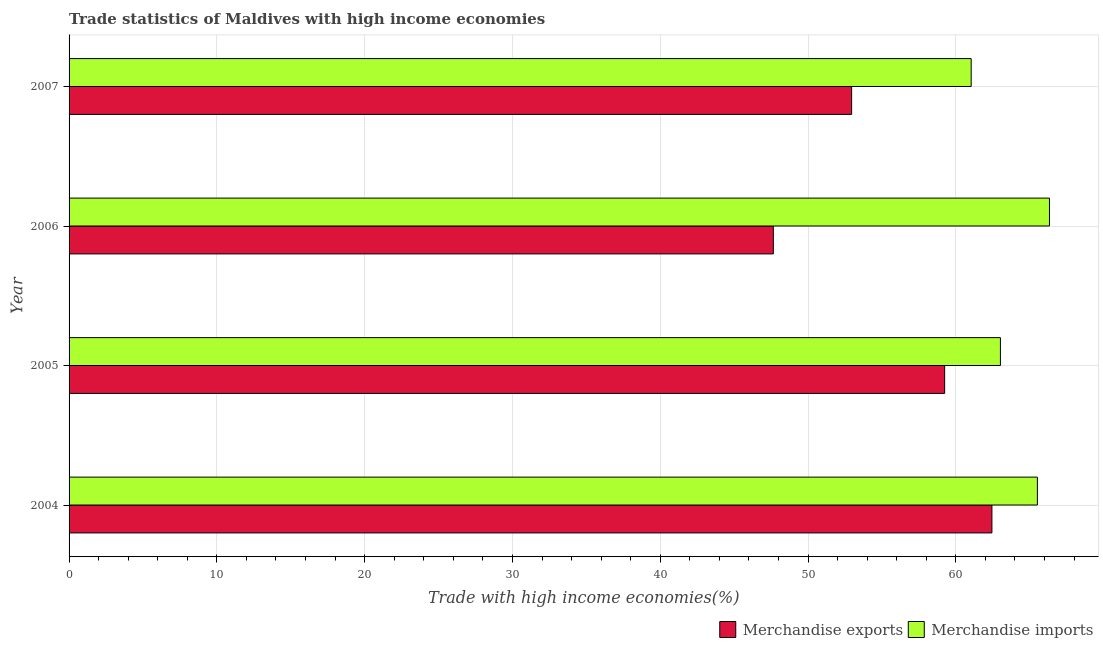How many different coloured bars are there?
Your answer should be compact. 2. How many groups of bars are there?
Keep it short and to the point. 4. Are the number of bars on each tick of the Y-axis equal?
Offer a terse response. Yes. How many bars are there on the 2nd tick from the top?
Your answer should be very brief. 2. How many bars are there on the 4th tick from the bottom?
Keep it short and to the point. 2. In how many cases, is the number of bars for a given year not equal to the number of legend labels?
Your response must be concise. 0. What is the merchandise imports in 2006?
Offer a terse response. 66.34. Across all years, what is the maximum merchandise imports?
Your response must be concise. 66.34. Across all years, what is the minimum merchandise imports?
Provide a short and direct response. 61.04. What is the total merchandise imports in the graph?
Keep it short and to the point. 255.92. What is the difference between the merchandise exports in 2004 and that in 2007?
Offer a very short reply. 9.49. What is the difference between the merchandise imports in 2006 and the merchandise exports in 2005?
Offer a very short reply. 7.09. What is the average merchandise imports per year?
Give a very brief answer. 63.98. In the year 2005, what is the difference between the merchandise exports and merchandise imports?
Your answer should be compact. -3.77. In how many years, is the merchandise exports greater than 42 %?
Offer a very short reply. 4. What is the ratio of the merchandise exports in 2004 to that in 2005?
Offer a very short reply. 1.05. Is the merchandise exports in 2004 less than that in 2005?
Provide a succinct answer. No. What is the difference between the highest and the second highest merchandise imports?
Make the answer very short. 0.82. What is the difference between the highest and the lowest merchandise imports?
Offer a terse response. 5.3. What does the 2nd bar from the top in 2006 represents?
Your answer should be compact. Merchandise exports. What does the 1st bar from the bottom in 2004 represents?
Provide a short and direct response. Merchandise exports. How many bars are there?
Your response must be concise. 8. Are all the bars in the graph horizontal?
Provide a succinct answer. Yes. How many years are there in the graph?
Give a very brief answer. 4. What is the difference between two consecutive major ticks on the X-axis?
Ensure brevity in your answer.  10. Does the graph contain any zero values?
Provide a short and direct response. No. What is the title of the graph?
Keep it short and to the point. Trade statistics of Maldives with high income economies. What is the label or title of the X-axis?
Offer a very short reply. Trade with high income economies(%). What is the Trade with high income economies(%) of Merchandise exports in 2004?
Offer a terse response. 62.44. What is the Trade with high income economies(%) in Merchandise imports in 2004?
Keep it short and to the point. 65.52. What is the Trade with high income economies(%) of Merchandise exports in 2005?
Offer a very short reply. 59.24. What is the Trade with high income economies(%) in Merchandise imports in 2005?
Give a very brief answer. 63.02. What is the Trade with high income economies(%) in Merchandise exports in 2006?
Offer a very short reply. 47.65. What is the Trade with high income economies(%) in Merchandise imports in 2006?
Offer a terse response. 66.34. What is the Trade with high income economies(%) of Merchandise exports in 2007?
Provide a short and direct response. 52.95. What is the Trade with high income economies(%) of Merchandise imports in 2007?
Your answer should be compact. 61.04. Across all years, what is the maximum Trade with high income economies(%) of Merchandise exports?
Ensure brevity in your answer.  62.44. Across all years, what is the maximum Trade with high income economies(%) in Merchandise imports?
Ensure brevity in your answer.  66.34. Across all years, what is the minimum Trade with high income economies(%) of Merchandise exports?
Ensure brevity in your answer.  47.65. Across all years, what is the minimum Trade with high income economies(%) of Merchandise imports?
Make the answer very short. 61.04. What is the total Trade with high income economies(%) of Merchandise exports in the graph?
Make the answer very short. 222.29. What is the total Trade with high income economies(%) of Merchandise imports in the graph?
Ensure brevity in your answer.  255.92. What is the difference between the Trade with high income economies(%) in Merchandise exports in 2004 and that in 2005?
Offer a very short reply. 3.2. What is the difference between the Trade with high income economies(%) of Merchandise imports in 2004 and that in 2005?
Your answer should be compact. 2.5. What is the difference between the Trade with high income economies(%) of Merchandise exports in 2004 and that in 2006?
Give a very brief answer. 14.79. What is the difference between the Trade with high income economies(%) in Merchandise imports in 2004 and that in 2006?
Your answer should be very brief. -0.82. What is the difference between the Trade with high income economies(%) in Merchandise exports in 2004 and that in 2007?
Your answer should be compact. 9.49. What is the difference between the Trade with high income economies(%) in Merchandise imports in 2004 and that in 2007?
Provide a succinct answer. 4.48. What is the difference between the Trade with high income economies(%) of Merchandise exports in 2005 and that in 2006?
Keep it short and to the point. 11.59. What is the difference between the Trade with high income economies(%) of Merchandise imports in 2005 and that in 2006?
Your answer should be very brief. -3.32. What is the difference between the Trade with high income economies(%) in Merchandise exports in 2005 and that in 2007?
Provide a succinct answer. 6.29. What is the difference between the Trade with high income economies(%) of Merchandise imports in 2005 and that in 2007?
Make the answer very short. 1.98. What is the difference between the Trade with high income economies(%) of Merchandise exports in 2006 and that in 2007?
Make the answer very short. -5.3. What is the difference between the Trade with high income economies(%) in Merchandise imports in 2006 and that in 2007?
Make the answer very short. 5.3. What is the difference between the Trade with high income economies(%) of Merchandise exports in 2004 and the Trade with high income economies(%) of Merchandise imports in 2005?
Offer a terse response. -0.57. What is the difference between the Trade with high income economies(%) of Merchandise exports in 2004 and the Trade with high income economies(%) of Merchandise imports in 2006?
Your answer should be very brief. -3.89. What is the difference between the Trade with high income economies(%) of Merchandise exports in 2004 and the Trade with high income economies(%) of Merchandise imports in 2007?
Give a very brief answer. 1.4. What is the difference between the Trade with high income economies(%) of Merchandise exports in 2005 and the Trade with high income economies(%) of Merchandise imports in 2006?
Give a very brief answer. -7.09. What is the difference between the Trade with high income economies(%) in Merchandise exports in 2005 and the Trade with high income economies(%) in Merchandise imports in 2007?
Keep it short and to the point. -1.79. What is the difference between the Trade with high income economies(%) in Merchandise exports in 2006 and the Trade with high income economies(%) in Merchandise imports in 2007?
Keep it short and to the point. -13.39. What is the average Trade with high income economies(%) in Merchandise exports per year?
Your response must be concise. 55.57. What is the average Trade with high income economies(%) in Merchandise imports per year?
Provide a succinct answer. 63.98. In the year 2004, what is the difference between the Trade with high income economies(%) in Merchandise exports and Trade with high income economies(%) in Merchandise imports?
Keep it short and to the point. -3.08. In the year 2005, what is the difference between the Trade with high income economies(%) of Merchandise exports and Trade with high income economies(%) of Merchandise imports?
Provide a succinct answer. -3.77. In the year 2006, what is the difference between the Trade with high income economies(%) of Merchandise exports and Trade with high income economies(%) of Merchandise imports?
Ensure brevity in your answer.  -18.69. In the year 2007, what is the difference between the Trade with high income economies(%) of Merchandise exports and Trade with high income economies(%) of Merchandise imports?
Your response must be concise. -8.09. What is the ratio of the Trade with high income economies(%) of Merchandise exports in 2004 to that in 2005?
Offer a terse response. 1.05. What is the ratio of the Trade with high income economies(%) in Merchandise imports in 2004 to that in 2005?
Your answer should be very brief. 1.04. What is the ratio of the Trade with high income economies(%) of Merchandise exports in 2004 to that in 2006?
Make the answer very short. 1.31. What is the ratio of the Trade with high income economies(%) of Merchandise exports in 2004 to that in 2007?
Offer a very short reply. 1.18. What is the ratio of the Trade with high income economies(%) of Merchandise imports in 2004 to that in 2007?
Ensure brevity in your answer.  1.07. What is the ratio of the Trade with high income economies(%) in Merchandise exports in 2005 to that in 2006?
Ensure brevity in your answer.  1.24. What is the ratio of the Trade with high income economies(%) in Merchandise exports in 2005 to that in 2007?
Provide a succinct answer. 1.12. What is the ratio of the Trade with high income economies(%) of Merchandise imports in 2005 to that in 2007?
Your response must be concise. 1.03. What is the ratio of the Trade with high income economies(%) in Merchandise exports in 2006 to that in 2007?
Keep it short and to the point. 0.9. What is the ratio of the Trade with high income economies(%) of Merchandise imports in 2006 to that in 2007?
Provide a short and direct response. 1.09. What is the difference between the highest and the second highest Trade with high income economies(%) of Merchandise exports?
Keep it short and to the point. 3.2. What is the difference between the highest and the second highest Trade with high income economies(%) of Merchandise imports?
Keep it short and to the point. 0.82. What is the difference between the highest and the lowest Trade with high income economies(%) in Merchandise exports?
Offer a terse response. 14.79. What is the difference between the highest and the lowest Trade with high income economies(%) in Merchandise imports?
Offer a very short reply. 5.3. 